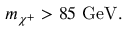Convert formula to latex. <formula><loc_0><loc_0><loc_500><loc_500>m _ { \chi ^ { + } } > 8 5 G e V .</formula> 